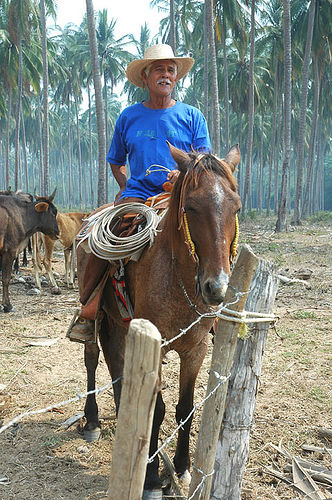<image>Is this man angry? I am not sure if the man is angry. Is this man angry? I am not sure if the man is angry. But it is more likely that he is not angry. 